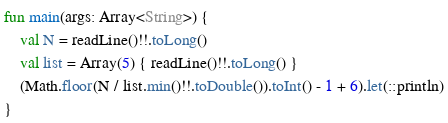Convert code to text. <code><loc_0><loc_0><loc_500><loc_500><_Kotlin_>fun main(args: Array<String>) {
    val N = readLine()!!.toLong()
    val list = Array(5) { readLine()!!.toLong() }
    (Math.floor(N / list.min()!!.toDouble()).toInt() - 1 + 6).let(::println)
}

</code> 